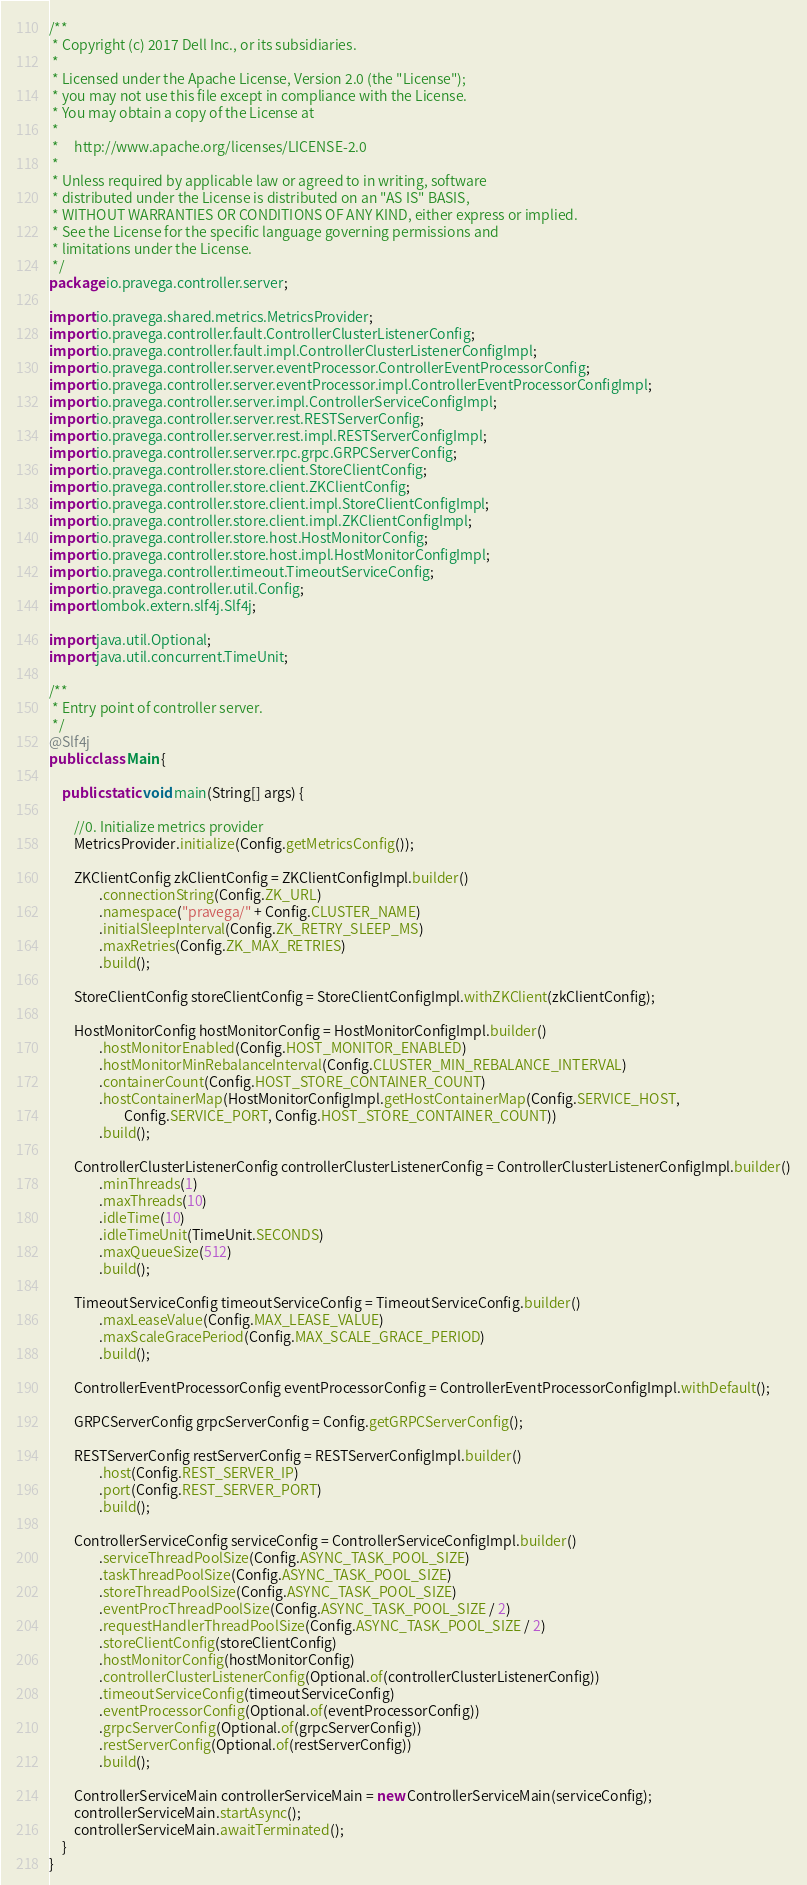<code> <loc_0><loc_0><loc_500><loc_500><_Java_>/**
 * Copyright (c) 2017 Dell Inc., or its subsidiaries.
 *
 * Licensed under the Apache License, Version 2.0 (the "License");
 * you may not use this file except in compliance with the License.
 * You may obtain a copy of the License at
 *
 *     http://www.apache.org/licenses/LICENSE-2.0
 *
 * Unless required by applicable law or agreed to in writing, software
 * distributed under the License is distributed on an "AS IS" BASIS,
 * WITHOUT WARRANTIES OR CONDITIONS OF ANY KIND, either express or implied.
 * See the License for the specific language governing permissions and
 * limitations under the License.
 */
package io.pravega.controller.server;

import io.pravega.shared.metrics.MetricsProvider;
import io.pravega.controller.fault.ControllerClusterListenerConfig;
import io.pravega.controller.fault.impl.ControllerClusterListenerConfigImpl;
import io.pravega.controller.server.eventProcessor.ControllerEventProcessorConfig;
import io.pravega.controller.server.eventProcessor.impl.ControllerEventProcessorConfigImpl;
import io.pravega.controller.server.impl.ControllerServiceConfigImpl;
import io.pravega.controller.server.rest.RESTServerConfig;
import io.pravega.controller.server.rest.impl.RESTServerConfigImpl;
import io.pravega.controller.server.rpc.grpc.GRPCServerConfig;
import io.pravega.controller.store.client.StoreClientConfig;
import io.pravega.controller.store.client.ZKClientConfig;
import io.pravega.controller.store.client.impl.StoreClientConfigImpl;
import io.pravega.controller.store.client.impl.ZKClientConfigImpl;
import io.pravega.controller.store.host.HostMonitorConfig;
import io.pravega.controller.store.host.impl.HostMonitorConfigImpl;
import io.pravega.controller.timeout.TimeoutServiceConfig;
import io.pravega.controller.util.Config;
import lombok.extern.slf4j.Slf4j;

import java.util.Optional;
import java.util.concurrent.TimeUnit;

/**
 * Entry point of controller server.
 */
@Slf4j
public class Main {

    public static void main(String[] args) {

        //0. Initialize metrics provider
        MetricsProvider.initialize(Config.getMetricsConfig());

        ZKClientConfig zkClientConfig = ZKClientConfigImpl.builder()
                .connectionString(Config.ZK_URL)
                .namespace("pravega/" + Config.CLUSTER_NAME)
                .initialSleepInterval(Config.ZK_RETRY_SLEEP_MS)
                .maxRetries(Config.ZK_MAX_RETRIES)
                .build();

        StoreClientConfig storeClientConfig = StoreClientConfigImpl.withZKClient(zkClientConfig);

        HostMonitorConfig hostMonitorConfig = HostMonitorConfigImpl.builder()
                .hostMonitorEnabled(Config.HOST_MONITOR_ENABLED)
                .hostMonitorMinRebalanceInterval(Config.CLUSTER_MIN_REBALANCE_INTERVAL)
                .containerCount(Config.HOST_STORE_CONTAINER_COUNT)
                .hostContainerMap(HostMonitorConfigImpl.getHostContainerMap(Config.SERVICE_HOST,
                        Config.SERVICE_PORT, Config.HOST_STORE_CONTAINER_COUNT))
                .build();

        ControllerClusterListenerConfig controllerClusterListenerConfig = ControllerClusterListenerConfigImpl.builder()
                .minThreads(1)
                .maxThreads(10)
                .idleTime(10)
                .idleTimeUnit(TimeUnit.SECONDS)
                .maxQueueSize(512)
                .build();

        TimeoutServiceConfig timeoutServiceConfig = TimeoutServiceConfig.builder()
                .maxLeaseValue(Config.MAX_LEASE_VALUE)
                .maxScaleGracePeriod(Config.MAX_SCALE_GRACE_PERIOD)
                .build();

        ControllerEventProcessorConfig eventProcessorConfig = ControllerEventProcessorConfigImpl.withDefault();

        GRPCServerConfig grpcServerConfig = Config.getGRPCServerConfig();

        RESTServerConfig restServerConfig = RESTServerConfigImpl.builder()
                .host(Config.REST_SERVER_IP)
                .port(Config.REST_SERVER_PORT)
                .build();

        ControllerServiceConfig serviceConfig = ControllerServiceConfigImpl.builder()
                .serviceThreadPoolSize(Config.ASYNC_TASK_POOL_SIZE)
                .taskThreadPoolSize(Config.ASYNC_TASK_POOL_SIZE)
                .storeThreadPoolSize(Config.ASYNC_TASK_POOL_SIZE)
                .eventProcThreadPoolSize(Config.ASYNC_TASK_POOL_SIZE / 2)
                .requestHandlerThreadPoolSize(Config.ASYNC_TASK_POOL_SIZE / 2)
                .storeClientConfig(storeClientConfig)
                .hostMonitorConfig(hostMonitorConfig)
                .controllerClusterListenerConfig(Optional.of(controllerClusterListenerConfig))
                .timeoutServiceConfig(timeoutServiceConfig)
                .eventProcessorConfig(Optional.of(eventProcessorConfig))
                .grpcServerConfig(Optional.of(grpcServerConfig))
                .restServerConfig(Optional.of(restServerConfig))
                .build();

        ControllerServiceMain controllerServiceMain = new ControllerServiceMain(serviceConfig);
        controllerServiceMain.startAsync();
        controllerServiceMain.awaitTerminated();
    }
}
</code> 